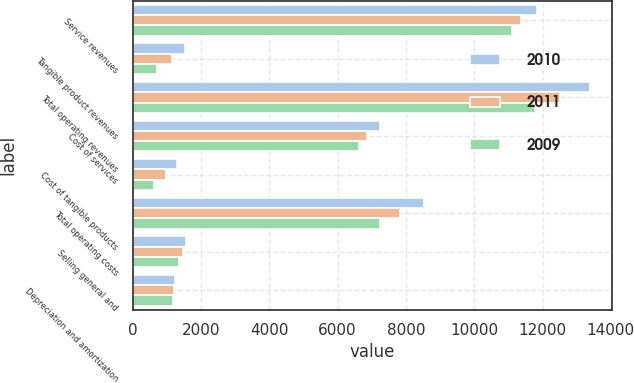Convert chart to OTSL. <chart><loc_0><loc_0><loc_500><loc_500><stacked_bar_chart><ecel><fcel>Service revenues<fcel>Tangible product revenues<fcel>Total operating revenues<fcel>Cost of services<fcel>Cost of tangible products<fcel>Total operating costs<fcel>Selling general and<fcel>Depreciation and amortization<nl><fcel>2010<fcel>11852<fcel>1526<fcel>13378<fcel>7254<fcel>1287<fcel>8541<fcel>1551<fcel>1229<nl><fcel>2011<fcel>11371<fcel>1144<fcel>12515<fcel>6854<fcel>970<fcel>7824<fcel>1461<fcel>1194<nl><fcel>2009<fcel>11093<fcel>698<fcel>11791<fcel>6620<fcel>621<fcel>7241<fcel>1364<fcel>1166<nl></chart> 